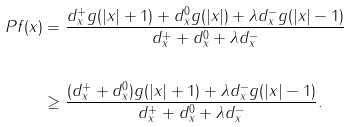<formula> <loc_0><loc_0><loc_500><loc_500>P f ( x ) & = \frac { d _ { x } ^ { + } g ( | x | + 1 ) + d _ { x } ^ { 0 } g ( | x | ) + \lambda d _ { x } ^ { - } g ( | x | - 1 ) } { d _ { x } ^ { + } + d _ { x } ^ { 0 } + \lambda d _ { x } ^ { - } } \\ \, \\ & \geq \frac { ( d _ { x } ^ { + } + d _ { x } ^ { 0 } ) g ( | x | + 1 ) + \lambda d _ { x } ^ { - } g ( | x | - 1 ) } { d _ { x } ^ { + } + d _ { x } ^ { 0 } + \lambda d _ { x } ^ { - } } .</formula> 